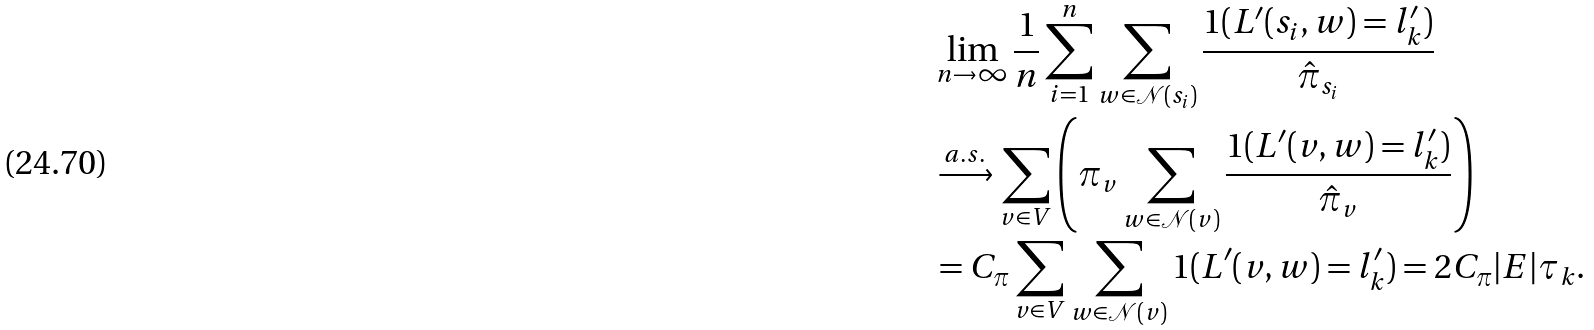<formula> <loc_0><loc_0><loc_500><loc_500>& \lim _ { n \rightarrow \infty } \frac { 1 } { n } \sum _ { i = 1 } ^ { n } \sum _ { w \in \mathcal { N } ( s _ { i } ) } \frac { 1 ( L ^ { \prime } ( s _ { i } , w ) = l _ { k } ^ { \prime } ) } { \hat { \pi } _ { s _ { i } } } \\ & \xrightarrow { a . s . } \sum _ { v \in V } \left ( \pi _ { v } \sum _ { w \in \mathcal { N } ( v ) } \frac { 1 ( L ^ { \prime } ( v , w ) = l _ { k } ^ { \prime } ) } { \hat { \pi } _ { v } } \right ) \\ & = C _ { \pi } \sum _ { v \in V } \sum _ { w \in \mathcal { N } ( v ) } 1 ( L ^ { \prime } ( v , w ) = l _ { k } ^ { \prime } ) = 2 C _ { \pi } | E | \tau _ { k } .</formula> 